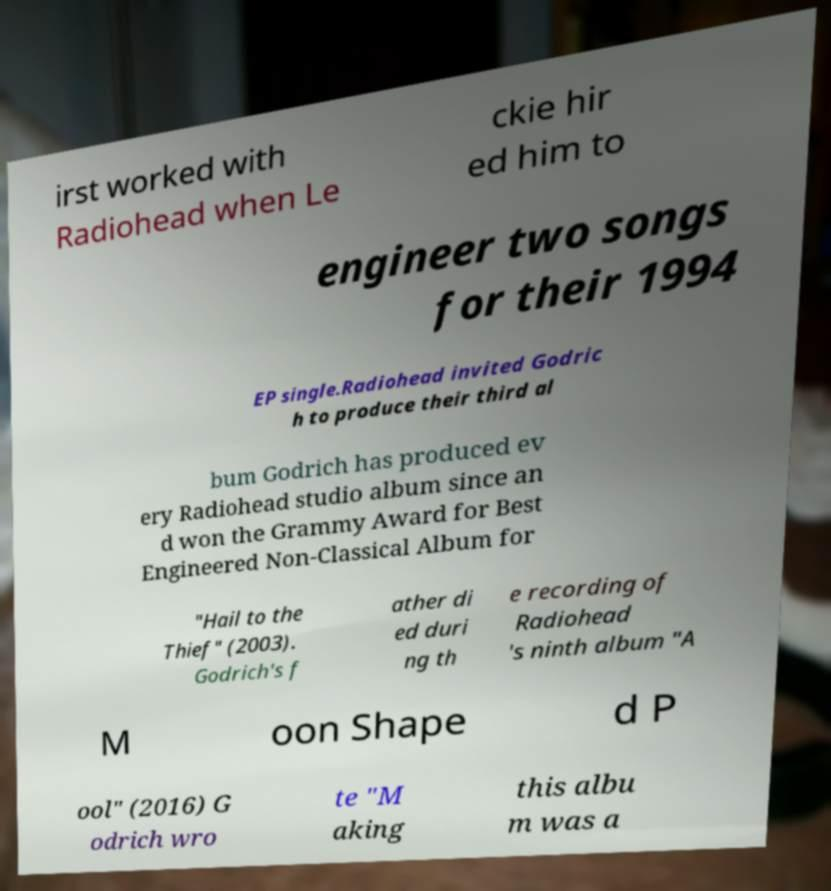I need the written content from this picture converted into text. Can you do that? irst worked with Radiohead when Le ckie hir ed him to engineer two songs for their 1994 EP single.Radiohead invited Godric h to produce their third al bum Godrich has produced ev ery Radiohead studio album since an d won the Grammy Award for Best Engineered Non-Classical Album for "Hail to the Thief" (2003). Godrich's f ather di ed duri ng th e recording of Radiohead 's ninth album "A M oon Shape d P ool" (2016) G odrich wro te "M aking this albu m was a 